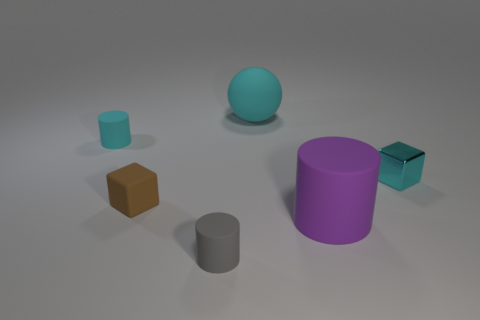Add 3 tiny cylinders. How many objects exist? 9 Subtract all cubes. How many objects are left? 4 Add 5 big rubber cylinders. How many big rubber cylinders exist? 6 Subtract 0 gray cubes. How many objects are left? 6 Subtract all green cylinders. Subtract all small gray things. How many objects are left? 5 Add 3 small shiny blocks. How many small shiny blocks are left? 4 